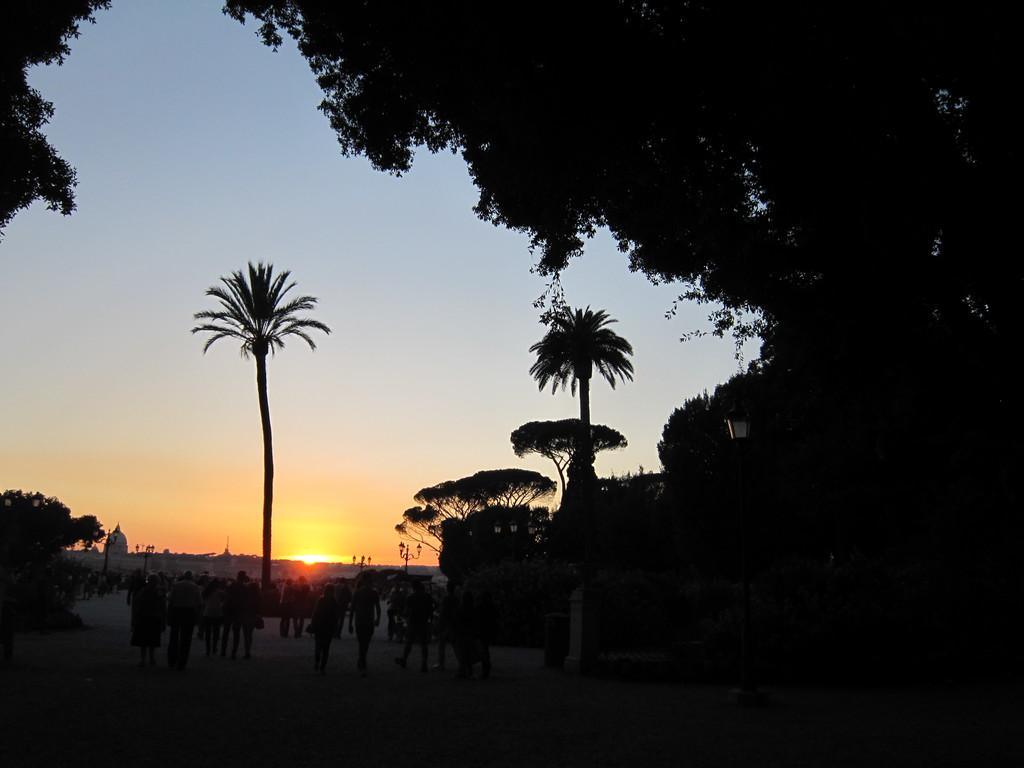What is happening in the image? There is a group of people standing in the image. What can be seen in the image besides the people? There are trees in the image. What is visible in the background of the image? The sky is visible in the background of the image. What type of bell can be heard ringing in the image? There is no bell present in the image, and therefore no sound can be heard. 